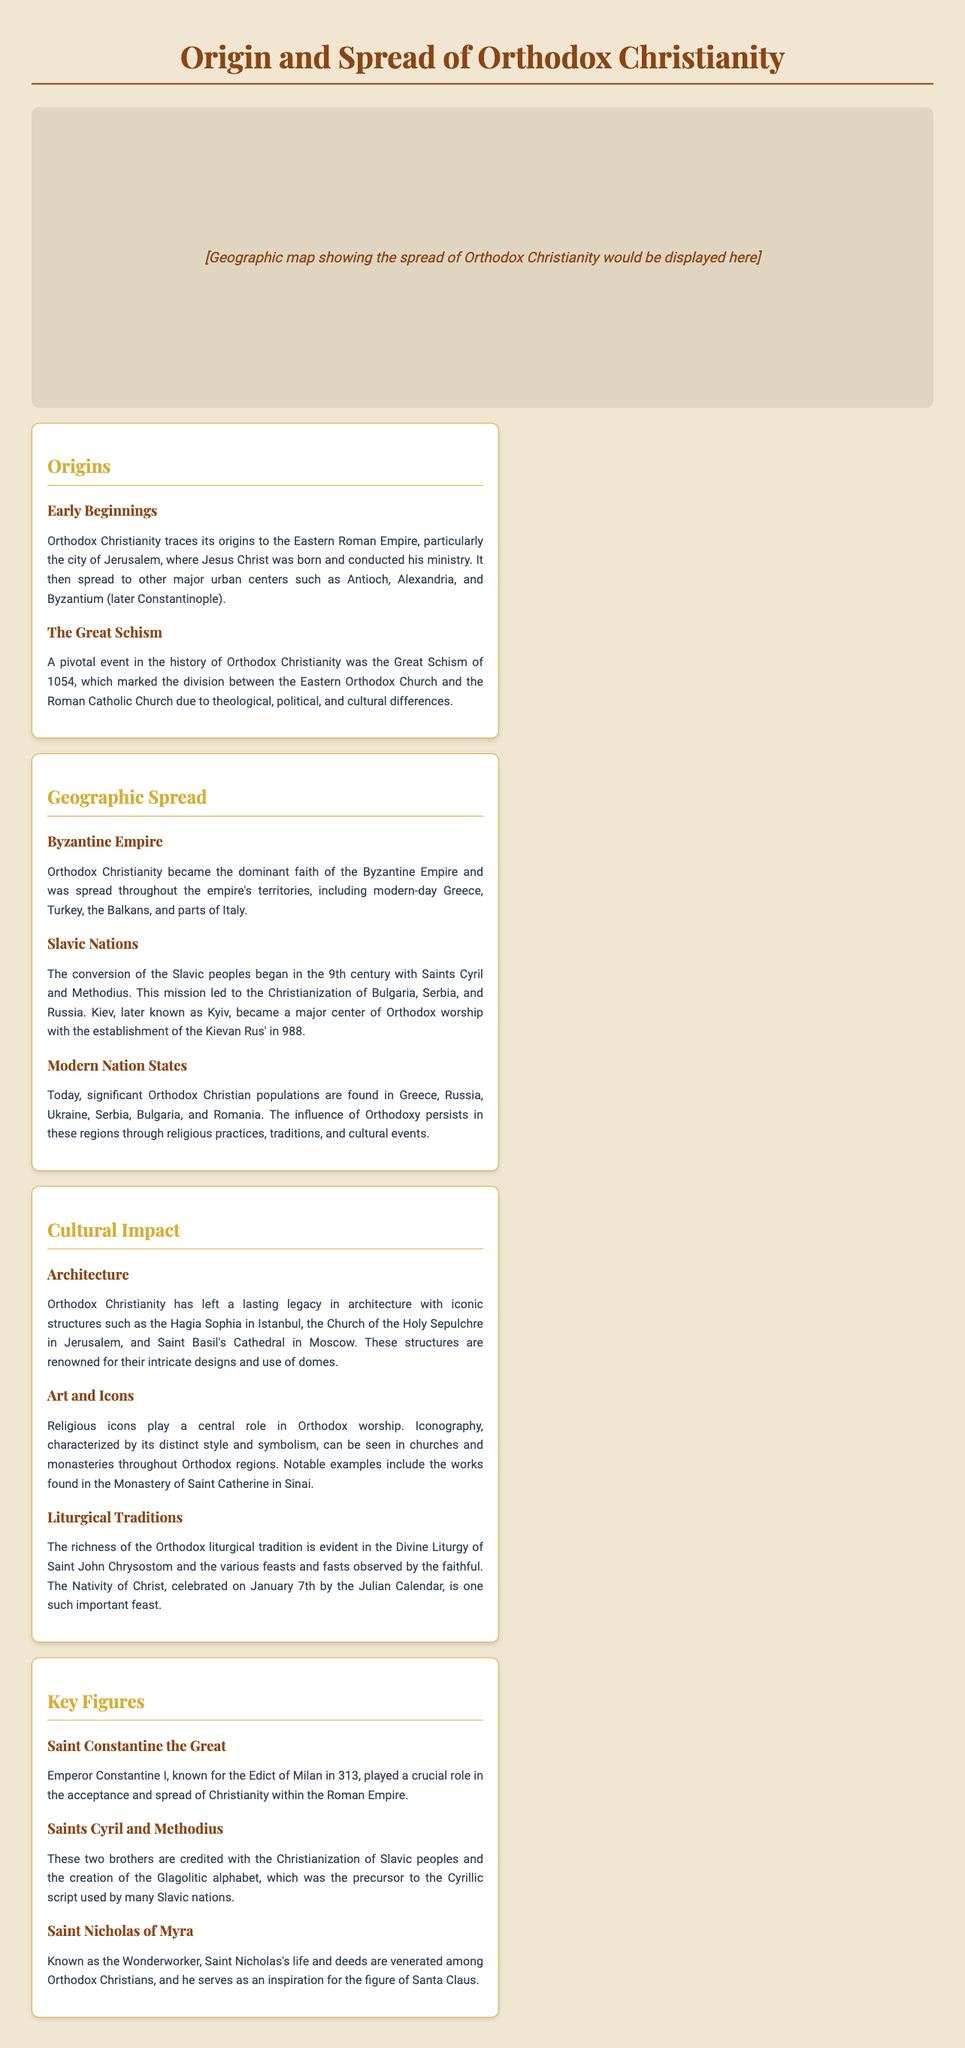What city is considered the origin of Orthodox Christianity? The document states that Orthodox Christianity traces its origins to the city of Jerusalem.
Answer: Jerusalem What significant event occurred in 1054? The document mentions that the Great Schism of 1054 marked the division between the Eastern Orthodox Church and the Roman Catholic Church.
Answer: Great Schism Which two saints were instrumental in the Christianization of the Slavic peoples? The document notes that Saints Cyril and Methodius were credited with this effort.
Answer: Saints Cyril and Methodius Which empire was central to the spread of Orthodox Christianity? The document states that Orthodox Christianity became the dominant faith of the Byzantine Empire.
Answer: Byzantine Empire What important feast is celebrated on January 7th? The document indicates that the Nativity of Christ is celebrated on this date according to the Julian Calendar.
Answer: Nativity of Christ What architectural landmark is located in Istanbul? The document lists the Hagia Sophia as an iconic structure in Orthodox Christianity located in Istanbul.
Answer: Hagia Sophia Who played a crucial role in the acceptance of Christianity within the Roman Empire? The document mentions Emperor Constantine I for his pivotal actions.
Answer: Emperor Constantine I Which modern country has a significant Orthodox Christian population that was part of the Byzantine Empire? The document describes that modern-day Greece has a significant Orthodox Christian population.
Answer: Greece What is the precursor to the Cyrillic script created by Saints Cyril and Methodius? The document states that the Glagolitic alphabet was the precursor to the Cyrillic script.
Answer: Glagolitic alphabet 